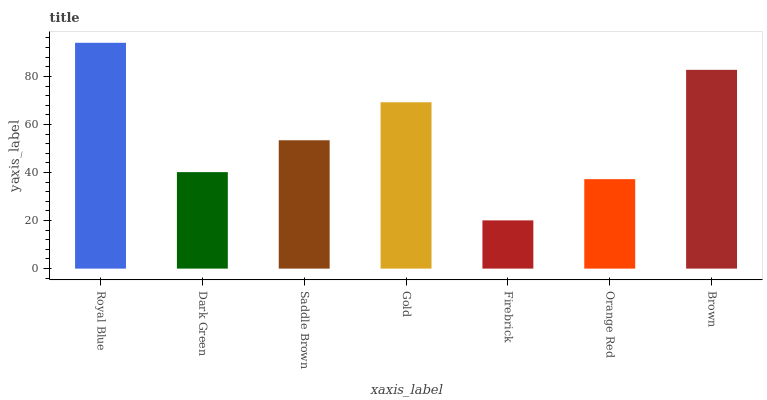Is Firebrick the minimum?
Answer yes or no. Yes. Is Royal Blue the maximum?
Answer yes or no. Yes. Is Dark Green the minimum?
Answer yes or no. No. Is Dark Green the maximum?
Answer yes or no. No. Is Royal Blue greater than Dark Green?
Answer yes or no. Yes. Is Dark Green less than Royal Blue?
Answer yes or no. Yes. Is Dark Green greater than Royal Blue?
Answer yes or no. No. Is Royal Blue less than Dark Green?
Answer yes or no. No. Is Saddle Brown the high median?
Answer yes or no. Yes. Is Saddle Brown the low median?
Answer yes or no. Yes. Is Dark Green the high median?
Answer yes or no. No. Is Firebrick the low median?
Answer yes or no. No. 